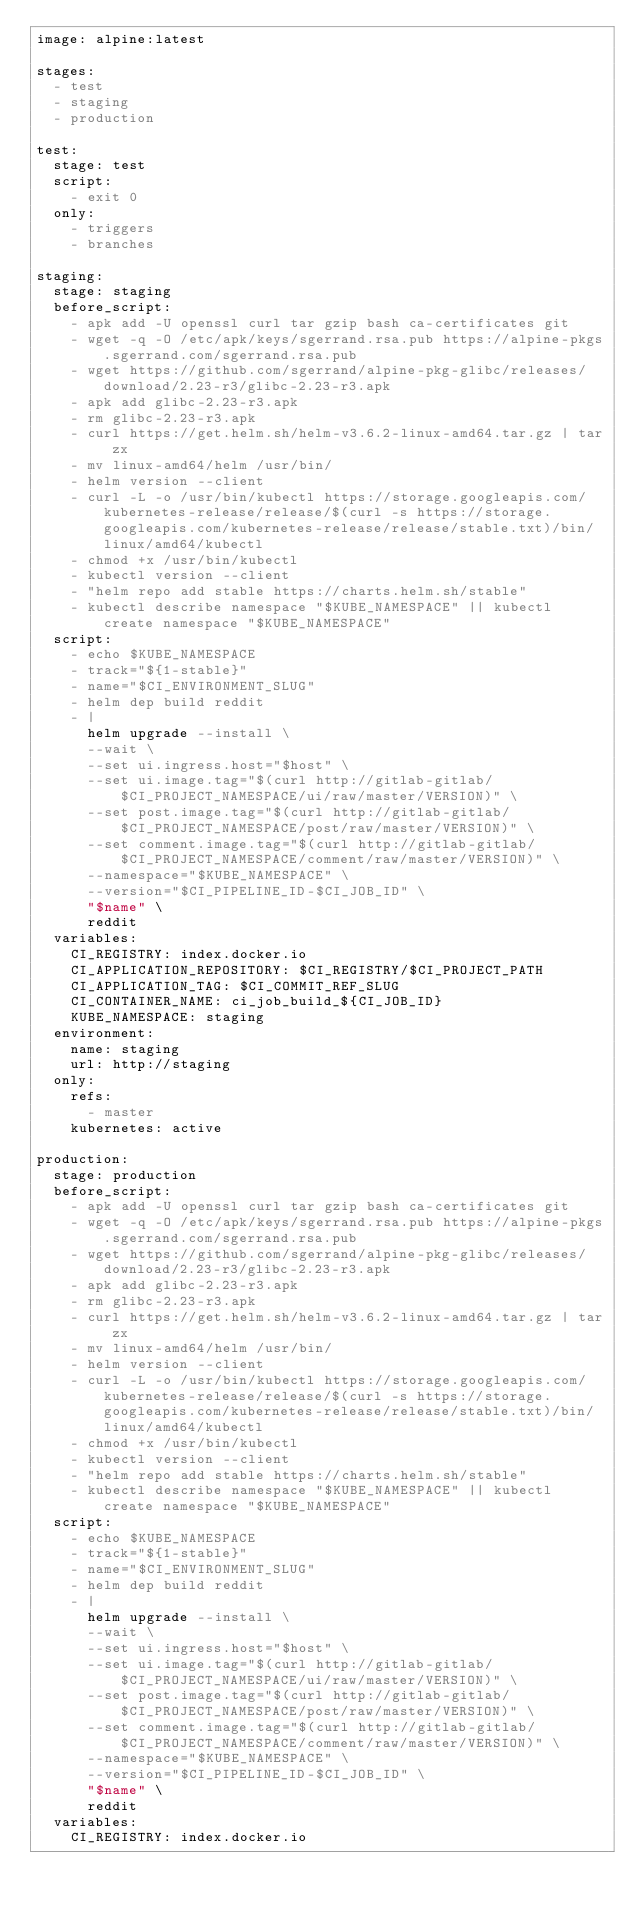Convert code to text. <code><loc_0><loc_0><loc_500><loc_500><_YAML_>image: alpine:latest

stages:
  - test
  - staging
  - production

test:
  stage: test
  script:
    - exit 0
  only:
    - triggers
    - branches

staging:
  stage: staging
  before_script:
    - apk add -U openssl curl tar gzip bash ca-certificates git
    - wget -q -O /etc/apk/keys/sgerrand.rsa.pub https://alpine-pkgs.sgerrand.com/sgerrand.rsa.pub
    - wget https://github.com/sgerrand/alpine-pkg-glibc/releases/download/2.23-r3/glibc-2.23-r3.apk
    - apk add glibc-2.23-r3.apk
    - rm glibc-2.23-r3.apk
    - curl https://get.helm.sh/helm-v3.6.2-linux-amd64.tar.gz | tar zx
    - mv linux-amd64/helm /usr/bin/
    - helm version --client
    - curl -L -o /usr/bin/kubectl https://storage.googleapis.com/kubernetes-release/release/$(curl -s https://storage.googleapis.com/kubernetes-release/release/stable.txt)/bin/linux/amd64/kubectl
    - chmod +x /usr/bin/kubectl
    - kubectl version --client
    - "helm repo add stable https://charts.helm.sh/stable"
    - kubectl describe namespace "$KUBE_NAMESPACE" || kubectl create namespace "$KUBE_NAMESPACE"
  script:
    - echo $KUBE_NAMESPACE
    - track="${1-stable}"
    - name="$CI_ENVIRONMENT_SLUG"
    - helm dep build reddit
    - |
      helm upgrade --install \
      --wait \
      --set ui.ingress.host="$host" \
      --set ui.image.tag="$(curl http://gitlab-gitlab/$CI_PROJECT_NAMESPACE/ui/raw/master/VERSION)" \
      --set post.image.tag="$(curl http://gitlab-gitlab/$CI_PROJECT_NAMESPACE/post/raw/master/VERSION)" \
      --set comment.image.tag="$(curl http://gitlab-gitlab/$CI_PROJECT_NAMESPACE/comment/raw/master/VERSION)" \
      --namespace="$KUBE_NAMESPACE" \
      --version="$CI_PIPELINE_ID-$CI_JOB_ID" \
      "$name" \
      reddit
  variables:
    CI_REGISTRY: index.docker.io
    CI_APPLICATION_REPOSITORY: $CI_REGISTRY/$CI_PROJECT_PATH
    CI_APPLICATION_TAG: $CI_COMMIT_REF_SLUG
    CI_CONTAINER_NAME: ci_job_build_${CI_JOB_ID}
    KUBE_NAMESPACE: staging
  environment:
    name: staging
    url: http://staging
  only:
    refs:
      - master
    kubernetes: active

production:
  stage: production
  before_script:
    - apk add -U openssl curl tar gzip bash ca-certificates git
    - wget -q -O /etc/apk/keys/sgerrand.rsa.pub https://alpine-pkgs.sgerrand.com/sgerrand.rsa.pub
    - wget https://github.com/sgerrand/alpine-pkg-glibc/releases/download/2.23-r3/glibc-2.23-r3.apk
    - apk add glibc-2.23-r3.apk
    - rm glibc-2.23-r3.apk
    - curl https://get.helm.sh/helm-v3.6.2-linux-amd64.tar.gz | tar zx
    - mv linux-amd64/helm /usr/bin/
    - helm version --client
    - curl -L -o /usr/bin/kubectl https://storage.googleapis.com/kubernetes-release/release/$(curl -s https://storage.googleapis.com/kubernetes-release/release/stable.txt)/bin/linux/amd64/kubectl
    - chmod +x /usr/bin/kubectl
    - kubectl version --client
    - "helm repo add stable https://charts.helm.sh/stable"
    - kubectl describe namespace "$KUBE_NAMESPACE" || kubectl create namespace "$KUBE_NAMESPACE"
  script:
    - echo $KUBE_NAMESPACE
    - track="${1-stable}"
    - name="$CI_ENVIRONMENT_SLUG"
    - helm dep build reddit
    - |
      helm upgrade --install \
      --wait \
      --set ui.ingress.host="$host" \
      --set ui.image.tag="$(curl http://gitlab-gitlab/$CI_PROJECT_NAMESPACE/ui/raw/master/VERSION)" \
      --set post.image.tag="$(curl http://gitlab-gitlab/$CI_PROJECT_NAMESPACE/post/raw/master/VERSION)" \
      --set comment.image.tag="$(curl http://gitlab-gitlab/$CI_PROJECT_NAMESPACE/comment/raw/master/VERSION)" \
      --namespace="$KUBE_NAMESPACE" \
      --version="$CI_PIPELINE_ID-$CI_JOB_ID" \
      "$name" \
      reddit
  variables:
    CI_REGISTRY: index.docker.io</code> 